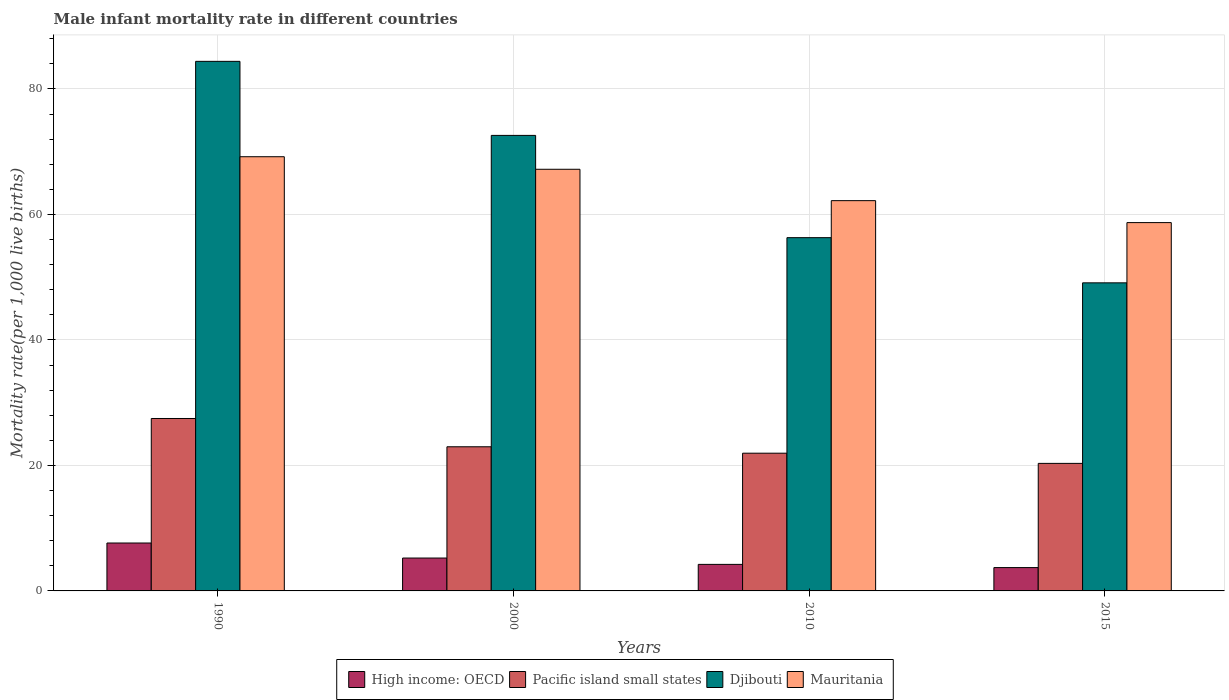How many different coloured bars are there?
Ensure brevity in your answer.  4. Are the number of bars per tick equal to the number of legend labels?
Provide a short and direct response. Yes. Are the number of bars on each tick of the X-axis equal?
Your response must be concise. Yes. How many bars are there on the 1st tick from the right?
Your answer should be very brief. 4. What is the label of the 1st group of bars from the left?
Provide a short and direct response. 1990. In how many cases, is the number of bars for a given year not equal to the number of legend labels?
Ensure brevity in your answer.  0. What is the male infant mortality rate in High income: OECD in 2000?
Your answer should be compact. 5.24. Across all years, what is the maximum male infant mortality rate in High income: OECD?
Keep it short and to the point. 7.64. Across all years, what is the minimum male infant mortality rate in Mauritania?
Give a very brief answer. 58.7. In which year was the male infant mortality rate in High income: OECD maximum?
Give a very brief answer. 1990. In which year was the male infant mortality rate in High income: OECD minimum?
Offer a terse response. 2015. What is the total male infant mortality rate in Mauritania in the graph?
Your response must be concise. 257.3. What is the difference between the male infant mortality rate in High income: OECD in 2010 and that in 2015?
Provide a short and direct response. 0.51. What is the difference between the male infant mortality rate in Mauritania in 2000 and the male infant mortality rate in Pacific island small states in 1990?
Your answer should be compact. 39.72. What is the average male infant mortality rate in Pacific island small states per year?
Provide a short and direct response. 23.18. In the year 2015, what is the difference between the male infant mortality rate in Mauritania and male infant mortality rate in Djibouti?
Your response must be concise. 9.6. In how many years, is the male infant mortality rate in Pacific island small states greater than 36?
Provide a short and direct response. 0. What is the ratio of the male infant mortality rate in Pacific island small states in 1990 to that in 2010?
Make the answer very short. 1.25. Is the male infant mortality rate in Pacific island small states in 2000 less than that in 2010?
Provide a succinct answer. No. Is the difference between the male infant mortality rate in Mauritania in 2010 and 2015 greater than the difference between the male infant mortality rate in Djibouti in 2010 and 2015?
Give a very brief answer. No. What is the difference between the highest and the lowest male infant mortality rate in High income: OECD?
Ensure brevity in your answer.  3.92. In how many years, is the male infant mortality rate in Pacific island small states greater than the average male infant mortality rate in Pacific island small states taken over all years?
Offer a terse response. 1. Is it the case that in every year, the sum of the male infant mortality rate in Mauritania and male infant mortality rate in Pacific island small states is greater than the sum of male infant mortality rate in Djibouti and male infant mortality rate in High income: OECD?
Give a very brief answer. No. What does the 1st bar from the left in 2015 represents?
Your answer should be compact. High income: OECD. What does the 3rd bar from the right in 2010 represents?
Offer a very short reply. Pacific island small states. Are all the bars in the graph horizontal?
Make the answer very short. No. How many years are there in the graph?
Ensure brevity in your answer.  4. How many legend labels are there?
Ensure brevity in your answer.  4. What is the title of the graph?
Offer a terse response. Male infant mortality rate in different countries. What is the label or title of the Y-axis?
Your answer should be very brief. Mortality rate(per 1,0 live births). What is the Mortality rate(per 1,000 live births) of High income: OECD in 1990?
Keep it short and to the point. 7.64. What is the Mortality rate(per 1,000 live births) of Pacific island small states in 1990?
Your answer should be very brief. 27.48. What is the Mortality rate(per 1,000 live births) of Djibouti in 1990?
Give a very brief answer. 84.4. What is the Mortality rate(per 1,000 live births) of Mauritania in 1990?
Ensure brevity in your answer.  69.2. What is the Mortality rate(per 1,000 live births) in High income: OECD in 2000?
Offer a terse response. 5.24. What is the Mortality rate(per 1,000 live births) of Pacific island small states in 2000?
Your response must be concise. 22.97. What is the Mortality rate(per 1,000 live births) in Djibouti in 2000?
Offer a terse response. 72.6. What is the Mortality rate(per 1,000 live births) in Mauritania in 2000?
Your response must be concise. 67.2. What is the Mortality rate(per 1,000 live births) in High income: OECD in 2010?
Offer a very short reply. 4.23. What is the Mortality rate(per 1,000 live births) of Pacific island small states in 2010?
Offer a terse response. 21.95. What is the Mortality rate(per 1,000 live births) in Djibouti in 2010?
Offer a very short reply. 56.3. What is the Mortality rate(per 1,000 live births) of Mauritania in 2010?
Offer a terse response. 62.2. What is the Mortality rate(per 1,000 live births) in High income: OECD in 2015?
Offer a terse response. 3.72. What is the Mortality rate(per 1,000 live births) of Pacific island small states in 2015?
Offer a very short reply. 20.33. What is the Mortality rate(per 1,000 live births) in Djibouti in 2015?
Keep it short and to the point. 49.1. What is the Mortality rate(per 1,000 live births) in Mauritania in 2015?
Your response must be concise. 58.7. Across all years, what is the maximum Mortality rate(per 1,000 live births) in High income: OECD?
Give a very brief answer. 7.64. Across all years, what is the maximum Mortality rate(per 1,000 live births) of Pacific island small states?
Ensure brevity in your answer.  27.48. Across all years, what is the maximum Mortality rate(per 1,000 live births) of Djibouti?
Offer a very short reply. 84.4. Across all years, what is the maximum Mortality rate(per 1,000 live births) in Mauritania?
Keep it short and to the point. 69.2. Across all years, what is the minimum Mortality rate(per 1,000 live births) of High income: OECD?
Keep it short and to the point. 3.72. Across all years, what is the minimum Mortality rate(per 1,000 live births) in Pacific island small states?
Offer a terse response. 20.33. Across all years, what is the minimum Mortality rate(per 1,000 live births) of Djibouti?
Ensure brevity in your answer.  49.1. Across all years, what is the minimum Mortality rate(per 1,000 live births) of Mauritania?
Your answer should be compact. 58.7. What is the total Mortality rate(per 1,000 live births) in High income: OECD in the graph?
Offer a terse response. 20.82. What is the total Mortality rate(per 1,000 live births) in Pacific island small states in the graph?
Your answer should be very brief. 92.73. What is the total Mortality rate(per 1,000 live births) of Djibouti in the graph?
Your answer should be compact. 262.4. What is the total Mortality rate(per 1,000 live births) in Mauritania in the graph?
Your response must be concise. 257.3. What is the difference between the Mortality rate(per 1,000 live births) of High income: OECD in 1990 and that in 2000?
Provide a succinct answer. 2.39. What is the difference between the Mortality rate(per 1,000 live births) of Pacific island small states in 1990 and that in 2000?
Offer a terse response. 4.51. What is the difference between the Mortality rate(per 1,000 live births) of Mauritania in 1990 and that in 2000?
Your answer should be very brief. 2. What is the difference between the Mortality rate(per 1,000 live births) of High income: OECD in 1990 and that in 2010?
Offer a terse response. 3.41. What is the difference between the Mortality rate(per 1,000 live births) in Pacific island small states in 1990 and that in 2010?
Provide a short and direct response. 5.53. What is the difference between the Mortality rate(per 1,000 live births) in Djibouti in 1990 and that in 2010?
Give a very brief answer. 28.1. What is the difference between the Mortality rate(per 1,000 live births) of High income: OECD in 1990 and that in 2015?
Ensure brevity in your answer.  3.92. What is the difference between the Mortality rate(per 1,000 live births) of Pacific island small states in 1990 and that in 2015?
Provide a short and direct response. 7.16. What is the difference between the Mortality rate(per 1,000 live births) of Djibouti in 1990 and that in 2015?
Make the answer very short. 35.3. What is the difference between the Mortality rate(per 1,000 live births) in High income: OECD in 2000 and that in 2010?
Provide a short and direct response. 1.01. What is the difference between the Mortality rate(per 1,000 live births) in Pacific island small states in 2000 and that in 2010?
Provide a succinct answer. 1.02. What is the difference between the Mortality rate(per 1,000 live births) in High income: OECD in 2000 and that in 2015?
Make the answer very short. 1.52. What is the difference between the Mortality rate(per 1,000 live births) in Pacific island small states in 2000 and that in 2015?
Provide a succinct answer. 2.65. What is the difference between the Mortality rate(per 1,000 live births) in Djibouti in 2000 and that in 2015?
Ensure brevity in your answer.  23.5. What is the difference between the Mortality rate(per 1,000 live births) of High income: OECD in 2010 and that in 2015?
Keep it short and to the point. 0.51. What is the difference between the Mortality rate(per 1,000 live births) in Pacific island small states in 2010 and that in 2015?
Keep it short and to the point. 1.62. What is the difference between the Mortality rate(per 1,000 live births) of High income: OECD in 1990 and the Mortality rate(per 1,000 live births) of Pacific island small states in 2000?
Give a very brief answer. -15.34. What is the difference between the Mortality rate(per 1,000 live births) of High income: OECD in 1990 and the Mortality rate(per 1,000 live births) of Djibouti in 2000?
Provide a succinct answer. -64.96. What is the difference between the Mortality rate(per 1,000 live births) in High income: OECD in 1990 and the Mortality rate(per 1,000 live births) in Mauritania in 2000?
Provide a succinct answer. -59.56. What is the difference between the Mortality rate(per 1,000 live births) in Pacific island small states in 1990 and the Mortality rate(per 1,000 live births) in Djibouti in 2000?
Provide a succinct answer. -45.12. What is the difference between the Mortality rate(per 1,000 live births) in Pacific island small states in 1990 and the Mortality rate(per 1,000 live births) in Mauritania in 2000?
Make the answer very short. -39.72. What is the difference between the Mortality rate(per 1,000 live births) in Djibouti in 1990 and the Mortality rate(per 1,000 live births) in Mauritania in 2000?
Keep it short and to the point. 17.2. What is the difference between the Mortality rate(per 1,000 live births) of High income: OECD in 1990 and the Mortality rate(per 1,000 live births) of Pacific island small states in 2010?
Provide a succinct answer. -14.32. What is the difference between the Mortality rate(per 1,000 live births) in High income: OECD in 1990 and the Mortality rate(per 1,000 live births) in Djibouti in 2010?
Ensure brevity in your answer.  -48.66. What is the difference between the Mortality rate(per 1,000 live births) in High income: OECD in 1990 and the Mortality rate(per 1,000 live births) in Mauritania in 2010?
Make the answer very short. -54.56. What is the difference between the Mortality rate(per 1,000 live births) of Pacific island small states in 1990 and the Mortality rate(per 1,000 live births) of Djibouti in 2010?
Provide a short and direct response. -28.82. What is the difference between the Mortality rate(per 1,000 live births) in Pacific island small states in 1990 and the Mortality rate(per 1,000 live births) in Mauritania in 2010?
Provide a succinct answer. -34.72. What is the difference between the Mortality rate(per 1,000 live births) of Djibouti in 1990 and the Mortality rate(per 1,000 live births) of Mauritania in 2010?
Offer a very short reply. 22.2. What is the difference between the Mortality rate(per 1,000 live births) in High income: OECD in 1990 and the Mortality rate(per 1,000 live births) in Pacific island small states in 2015?
Ensure brevity in your answer.  -12.69. What is the difference between the Mortality rate(per 1,000 live births) of High income: OECD in 1990 and the Mortality rate(per 1,000 live births) of Djibouti in 2015?
Ensure brevity in your answer.  -41.46. What is the difference between the Mortality rate(per 1,000 live births) of High income: OECD in 1990 and the Mortality rate(per 1,000 live births) of Mauritania in 2015?
Provide a short and direct response. -51.06. What is the difference between the Mortality rate(per 1,000 live births) of Pacific island small states in 1990 and the Mortality rate(per 1,000 live births) of Djibouti in 2015?
Your answer should be compact. -21.62. What is the difference between the Mortality rate(per 1,000 live births) in Pacific island small states in 1990 and the Mortality rate(per 1,000 live births) in Mauritania in 2015?
Give a very brief answer. -31.22. What is the difference between the Mortality rate(per 1,000 live births) in Djibouti in 1990 and the Mortality rate(per 1,000 live births) in Mauritania in 2015?
Provide a succinct answer. 25.7. What is the difference between the Mortality rate(per 1,000 live births) of High income: OECD in 2000 and the Mortality rate(per 1,000 live births) of Pacific island small states in 2010?
Give a very brief answer. -16.71. What is the difference between the Mortality rate(per 1,000 live births) in High income: OECD in 2000 and the Mortality rate(per 1,000 live births) in Djibouti in 2010?
Your response must be concise. -51.06. What is the difference between the Mortality rate(per 1,000 live births) in High income: OECD in 2000 and the Mortality rate(per 1,000 live births) in Mauritania in 2010?
Keep it short and to the point. -56.96. What is the difference between the Mortality rate(per 1,000 live births) of Pacific island small states in 2000 and the Mortality rate(per 1,000 live births) of Djibouti in 2010?
Offer a terse response. -33.33. What is the difference between the Mortality rate(per 1,000 live births) in Pacific island small states in 2000 and the Mortality rate(per 1,000 live births) in Mauritania in 2010?
Keep it short and to the point. -39.23. What is the difference between the Mortality rate(per 1,000 live births) of Djibouti in 2000 and the Mortality rate(per 1,000 live births) of Mauritania in 2010?
Provide a short and direct response. 10.4. What is the difference between the Mortality rate(per 1,000 live births) of High income: OECD in 2000 and the Mortality rate(per 1,000 live births) of Pacific island small states in 2015?
Keep it short and to the point. -15.09. What is the difference between the Mortality rate(per 1,000 live births) of High income: OECD in 2000 and the Mortality rate(per 1,000 live births) of Djibouti in 2015?
Your answer should be very brief. -43.86. What is the difference between the Mortality rate(per 1,000 live births) in High income: OECD in 2000 and the Mortality rate(per 1,000 live births) in Mauritania in 2015?
Your answer should be very brief. -53.46. What is the difference between the Mortality rate(per 1,000 live births) of Pacific island small states in 2000 and the Mortality rate(per 1,000 live births) of Djibouti in 2015?
Your response must be concise. -26.13. What is the difference between the Mortality rate(per 1,000 live births) of Pacific island small states in 2000 and the Mortality rate(per 1,000 live births) of Mauritania in 2015?
Provide a short and direct response. -35.73. What is the difference between the Mortality rate(per 1,000 live births) in Djibouti in 2000 and the Mortality rate(per 1,000 live births) in Mauritania in 2015?
Ensure brevity in your answer.  13.9. What is the difference between the Mortality rate(per 1,000 live births) in High income: OECD in 2010 and the Mortality rate(per 1,000 live births) in Pacific island small states in 2015?
Offer a terse response. -16.1. What is the difference between the Mortality rate(per 1,000 live births) in High income: OECD in 2010 and the Mortality rate(per 1,000 live births) in Djibouti in 2015?
Your answer should be very brief. -44.87. What is the difference between the Mortality rate(per 1,000 live births) of High income: OECD in 2010 and the Mortality rate(per 1,000 live births) of Mauritania in 2015?
Your response must be concise. -54.47. What is the difference between the Mortality rate(per 1,000 live births) of Pacific island small states in 2010 and the Mortality rate(per 1,000 live births) of Djibouti in 2015?
Make the answer very short. -27.15. What is the difference between the Mortality rate(per 1,000 live births) in Pacific island small states in 2010 and the Mortality rate(per 1,000 live births) in Mauritania in 2015?
Provide a short and direct response. -36.75. What is the average Mortality rate(per 1,000 live births) in High income: OECD per year?
Provide a succinct answer. 5.21. What is the average Mortality rate(per 1,000 live births) in Pacific island small states per year?
Keep it short and to the point. 23.18. What is the average Mortality rate(per 1,000 live births) in Djibouti per year?
Your answer should be very brief. 65.6. What is the average Mortality rate(per 1,000 live births) of Mauritania per year?
Offer a very short reply. 64.33. In the year 1990, what is the difference between the Mortality rate(per 1,000 live births) in High income: OECD and Mortality rate(per 1,000 live births) in Pacific island small states?
Offer a very short reply. -19.85. In the year 1990, what is the difference between the Mortality rate(per 1,000 live births) in High income: OECD and Mortality rate(per 1,000 live births) in Djibouti?
Offer a very short reply. -76.76. In the year 1990, what is the difference between the Mortality rate(per 1,000 live births) of High income: OECD and Mortality rate(per 1,000 live births) of Mauritania?
Make the answer very short. -61.56. In the year 1990, what is the difference between the Mortality rate(per 1,000 live births) in Pacific island small states and Mortality rate(per 1,000 live births) in Djibouti?
Keep it short and to the point. -56.92. In the year 1990, what is the difference between the Mortality rate(per 1,000 live births) in Pacific island small states and Mortality rate(per 1,000 live births) in Mauritania?
Keep it short and to the point. -41.72. In the year 2000, what is the difference between the Mortality rate(per 1,000 live births) of High income: OECD and Mortality rate(per 1,000 live births) of Pacific island small states?
Ensure brevity in your answer.  -17.73. In the year 2000, what is the difference between the Mortality rate(per 1,000 live births) of High income: OECD and Mortality rate(per 1,000 live births) of Djibouti?
Keep it short and to the point. -67.36. In the year 2000, what is the difference between the Mortality rate(per 1,000 live births) in High income: OECD and Mortality rate(per 1,000 live births) in Mauritania?
Offer a terse response. -61.96. In the year 2000, what is the difference between the Mortality rate(per 1,000 live births) of Pacific island small states and Mortality rate(per 1,000 live births) of Djibouti?
Give a very brief answer. -49.63. In the year 2000, what is the difference between the Mortality rate(per 1,000 live births) in Pacific island small states and Mortality rate(per 1,000 live births) in Mauritania?
Offer a terse response. -44.23. In the year 2000, what is the difference between the Mortality rate(per 1,000 live births) in Djibouti and Mortality rate(per 1,000 live births) in Mauritania?
Your answer should be very brief. 5.4. In the year 2010, what is the difference between the Mortality rate(per 1,000 live births) of High income: OECD and Mortality rate(per 1,000 live births) of Pacific island small states?
Make the answer very short. -17.72. In the year 2010, what is the difference between the Mortality rate(per 1,000 live births) of High income: OECD and Mortality rate(per 1,000 live births) of Djibouti?
Give a very brief answer. -52.07. In the year 2010, what is the difference between the Mortality rate(per 1,000 live births) in High income: OECD and Mortality rate(per 1,000 live births) in Mauritania?
Make the answer very short. -57.97. In the year 2010, what is the difference between the Mortality rate(per 1,000 live births) of Pacific island small states and Mortality rate(per 1,000 live births) of Djibouti?
Offer a terse response. -34.35. In the year 2010, what is the difference between the Mortality rate(per 1,000 live births) of Pacific island small states and Mortality rate(per 1,000 live births) of Mauritania?
Your response must be concise. -40.25. In the year 2010, what is the difference between the Mortality rate(per 1,000 live births) in Djibouti and Mortality rate(per 1,000 live births) in Mauritania?
Your answer should be compact. -5.9. In the year 2015, what is the difference between the Mortality rate(per 1,000 live births) in High income: OECD and Mortality rate(per 1,000 live births) in Pacific island small states?
Offer a terse response. -16.61. In the year 2015, what is the difference between the Mortality rate(per 1,000 live births) of High income: OECD and Mortality rate(per 1,000 live births) of Djibouti?
Offer a terse response. -45.38. In the year 2015, what is the difference between the Mortality rate(per 1,000 live births) in High income: OECD and Mortality rate(per 1,000 live births) in Mauritania?
Your response must be concise. -54.98. In the year 2015, what is the difference between the Mortality rate(per 1,000 live births) of Pacific island small states and Mortality rate(per 1,000 live births) of Djibouti?
Offer a terse response. -28.77. In the year 2015, what is the difference between the Mortality rate(per 1,000 live births) of Pacific island small states and Mortality rate(per 1,000 live births) of Mauritania?
Your response must be concise. -38.37. What is the ratio of the Mortality rate(per 1,000 live births) in High income: OECD in 1990 to that in 2000?
Make the answer very short. 1.46. What is the ratio of the Mortality rate(per 1,000 live births) in Pacific island small states in 1990 to that in 2000?
Give a very brief answer. 1.2. What is the ratio of the Mortality rate(per 1,000 live births) of Djibouti in 1990 to that in 2000?
Keep it short and to the point. 1.16. What is the ratio of the Mortality rate(per 1,000 live births) in Mauritania in 1990 to that in 2000?
Offer a very short reply. 1.03. What is the ratio of the Mortality rate(per 1,000 live births) in High income: OECD in 1990 to that in 2010?
Offer a very short reply. 1.81. What is the ratio of the Mortality rate(per 1,000 live births) in Pacific island small states in 1990 to that in 2010?
Offer a very short reply. 1.25. What is the ratio of the Mortality rate(per 1,000 live births) of Djibouti in 1990 to that in 2010?
Give a very brief answer. 1.5. What is the ratio of the Mortality rate(per 1,000 live births) in Mauritania in 1990 to that in 2010?
Offer a very short reply. 1.11. What is the ratio of the Mortality rate(per 1,000 live births) of High income: OECD in 1990 to that in 2015?
Your answer should be very brief. 2.05. What is the ratio of the Mortality rate(per 1,000 live births) of Pacific island small states in 1990 to that in 2015?
Your answer should be very brief. 1.35. What is the ratio of the Mortality rate(per 1,000 live births) of Djibouti in 1990 to that in 2015?
Provide a succinct answer. 1.72. What is the ratio of the Mortality rate(per 1,000 live births) of Mauritania in 1990 to that in 2015?
Provide a short and direct response. 1.18. What is the ratio of the Mortality rate(per 1,000 live births) in High income: OECD in 2000 to that in 2010?
Your response must be concise. 1.24. What is the ratio of the Mortality rate(per 1,000 live births) of Pacific island small states in 2000 to that in 2010?
Your answer should be very brief. 1.05. What is the ratio of the Mortality rate(per 1,000 live births) in Djibouti in 2000 to that in 2010?
Your answer should be compact. 1.29. What is the ratio of the Mortality rate(per 1,000 live births) in Mauritania in 2000 to that in 2010?
Provide a succinct answer. 1.08. What is the ratio of the Mortality rate(per 1,000 live births) in High income: OECD in 2000 to that in 2015?
Offer a very short reply. 1.41. What is the ratio of the Mortality rate(per 1,000 live births) of Pacific island small states in 2000 to that in 2015?
Your answer should be very brief. 1.13. What is the ratio of the Mortality rate(per 1,000 live births) of Djibouti in 2000 to that in 2015?
Your answer should be compact. 1.48. What is the ratio of the Mortality rate(per 1,000 live births) of Mauritania in 2000 to that in 2015?
Offer a terse response. 1.14. What is the ratio of the Mortality rate(per 1,000 live births) in High income: OECD in 2010 to that in 2015?
Provide a succinct answer. 1.14. What is the ratio of the Mortality rate(per 1,000 live births) in Pacific island small states in 2010 to that in 2015?
Your answer should be compact. 1.08. What is the ratio of the Mortality rate(per 1,000 live births) in Djibouti in 2010 to that in 2015?
Your response must be concise. 1.15. What is the ratio of the Mortality rate(per 1,000 live births) in Mauritania in 2010 to that in 2015?
Make the answer very short. 1.06. What is the difference between the highest and the second highest Mortality rate(per 1,000 live births) in High income: OECD?
Provide a succinct answer. 2.39. What is the difference between the highest and the second highest Mortality rate(per 1,000 live births) in Pacific island small states?
Provide a succinct answer. 4.51. What is the difference between the highest and the second highest Mortality rate(per 1,000 live births) in Djibouti?
Ensure brevity in your answer.  11.8. What is the difference between the highest and the lowest Mortality rate(per 1,000 live births) in High income: OECD?
Provide a short and direct response. 3.92. What is the difference between the highest and the lowest Mortality rate(per 1,000 live births) in Pacific island small states?
Give a very brief answer. 7.16. What is the difference between the highest and the lowest Mortality rate(per 1,000 live births) in Djibouti?
Provide a succinct answer. 35.3. 